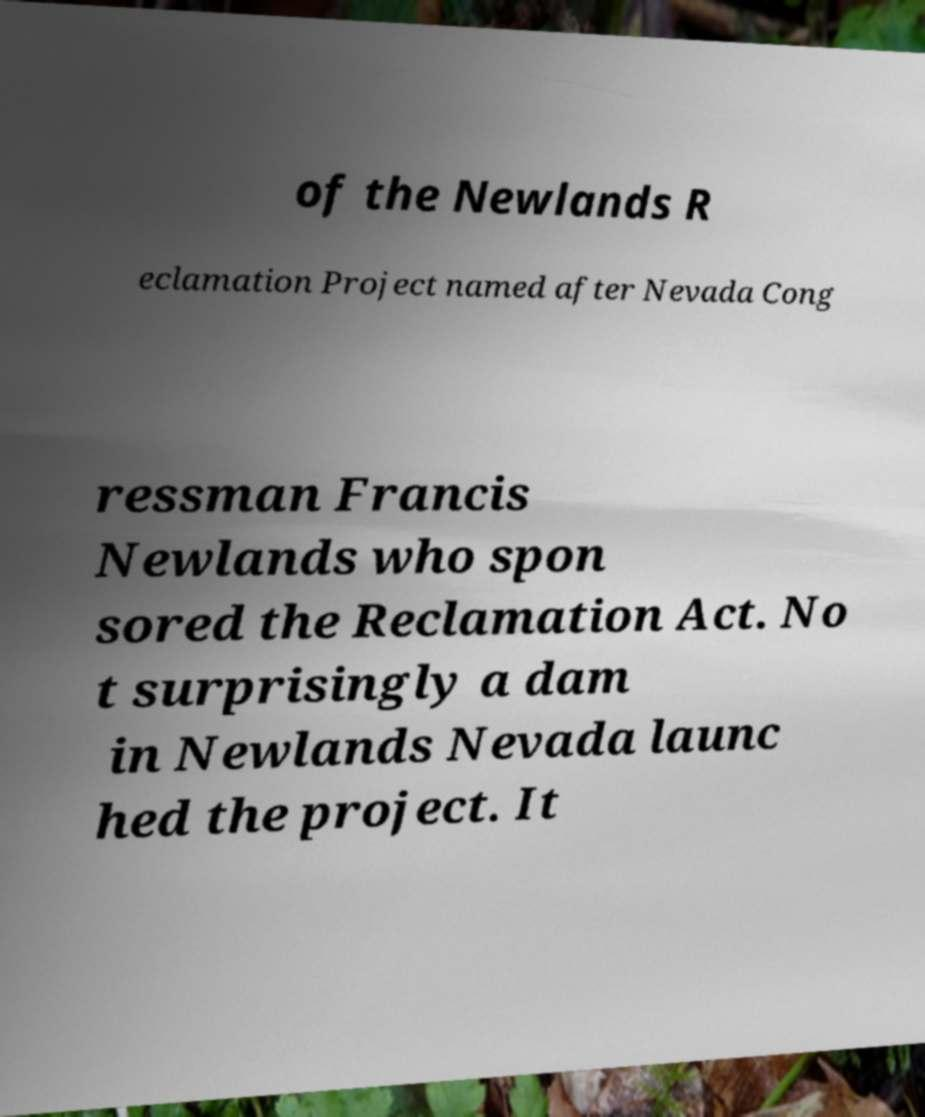Please identify and transcribe the text found in this image. of the Newlands R eclamation Project named after Nevada Cong ressman Francis Newlands who spon sored the Reclamation Act. No t surprisingly a dam in Newlands Nevada launc hed the project. It 